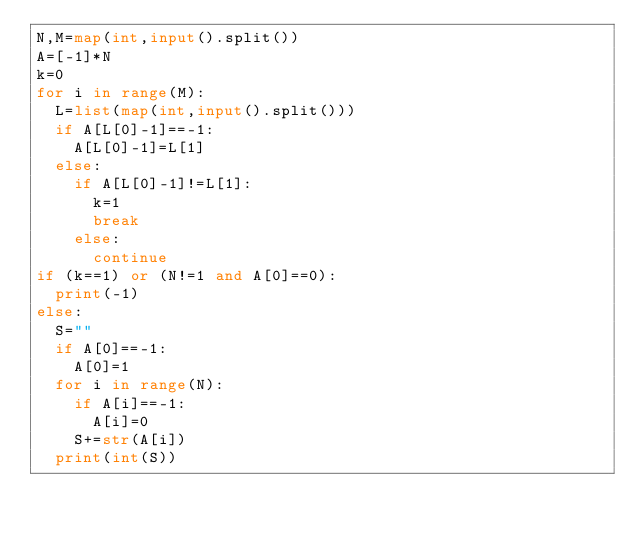<code> <loc_0><loc_0><loc_500><loc_500><_Python_>N,M=map(int,input().split())
A=[-1]*N
k=0
for i in range(M):
  L=list(map(int,input().split()))
  if A[L[0]-1]==-1:
    A[L[0]-1]=L[1]
  else:
    if A[L[0]-1]!=L[1]:
      k=1
      break
    else:
      continue
if (k==1) or (N!=1 and A[0]==0):
  print(-1)
else:
  S=""
  if A[0]==-1:
    A[0]=1
  for i in range(N):
    if A[i]==-1:
      A[i]=0
    S+=str(A[i])
  print(int(S))
      </code> 